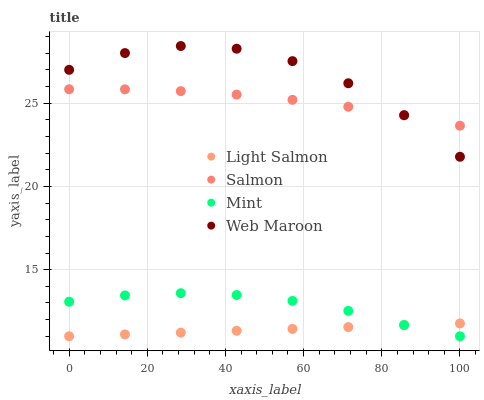Does Light Salmon have the minimum area under the curve?
Answer yes or no. Yes. Does Web Maroon have the maximum area under the curve?
Answer yes or no. Yes. Does Salmon have the minimum area under the curve?
Answer yes or no. No. Does Salmon have the maximum area under the curve?
Answer yes or no. No. Is Light Salmon the smoothest?
Answer yes or no. Yes. Is Web Maroon the roughest?
Answer yes or no. Yes. Is Salmon the smoothest?
Answer yes or no. No. Is Salmon the roughest?
Answer yes or no. No. Does Mint have the lowest value?
Answer yes or no. Yes. Does Salmon have the lowest value?
Answer yes or no. No. Does Web Maroon have the highest value?
Answer yes or no. Yes. Does Salmon have the highest value?
Answer yes or no. No. Is Mint less than Web Maroon?
Answer yes or no. Yes. Is Salmon greater than Mint?
Answer yes or no. Yes. Does Light Salmon intersect Mint?
Answer yes or no. Yes. Is Light Salmon less than Mint?
Answer yes or no. No. Is Light Salmon greater than Mint?
Answer yes or no. No. Does Mint intersect Web Maroon?
Answer yes or no. No. 